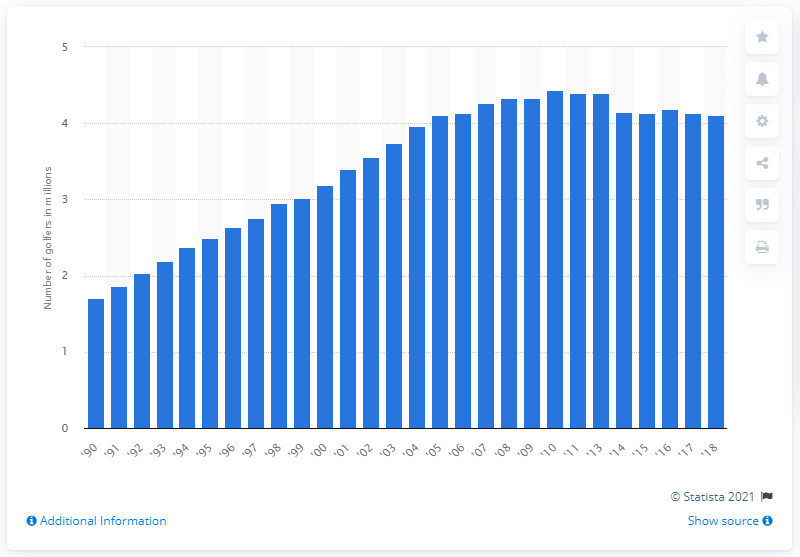Highlight a few significant elements in this photo. In 2010, 4.44 people were registered. In 1990, there were 1.71 registered golfers in Europe. 